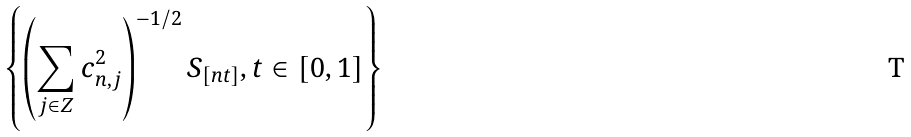<formula> <loc_0><loc_0><loc_500><loc_500>\left \{ \left ( \sum _ { j \in { Z } } c _ { n , j } ^ { 2 } \right ) ^ { - 1 / 2 } S _ { [ n t ] } , t \in [ 0 , 1 ] \right \}</formula> 